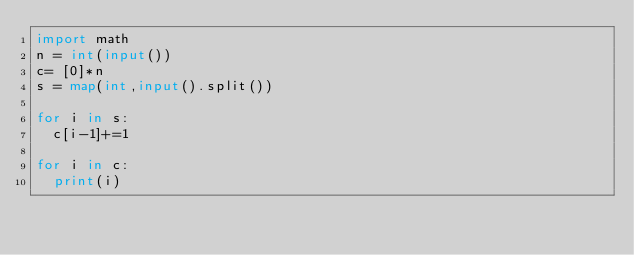Convert code to text. <code><loc_0><loc_0><loc_500><loc_500><_Python_>import math
n = int(input())
c= [0]*n
s = map(int,input().split())

for i in s:
  c[i-1]+=1

for i in c:
  print(i)</code> 